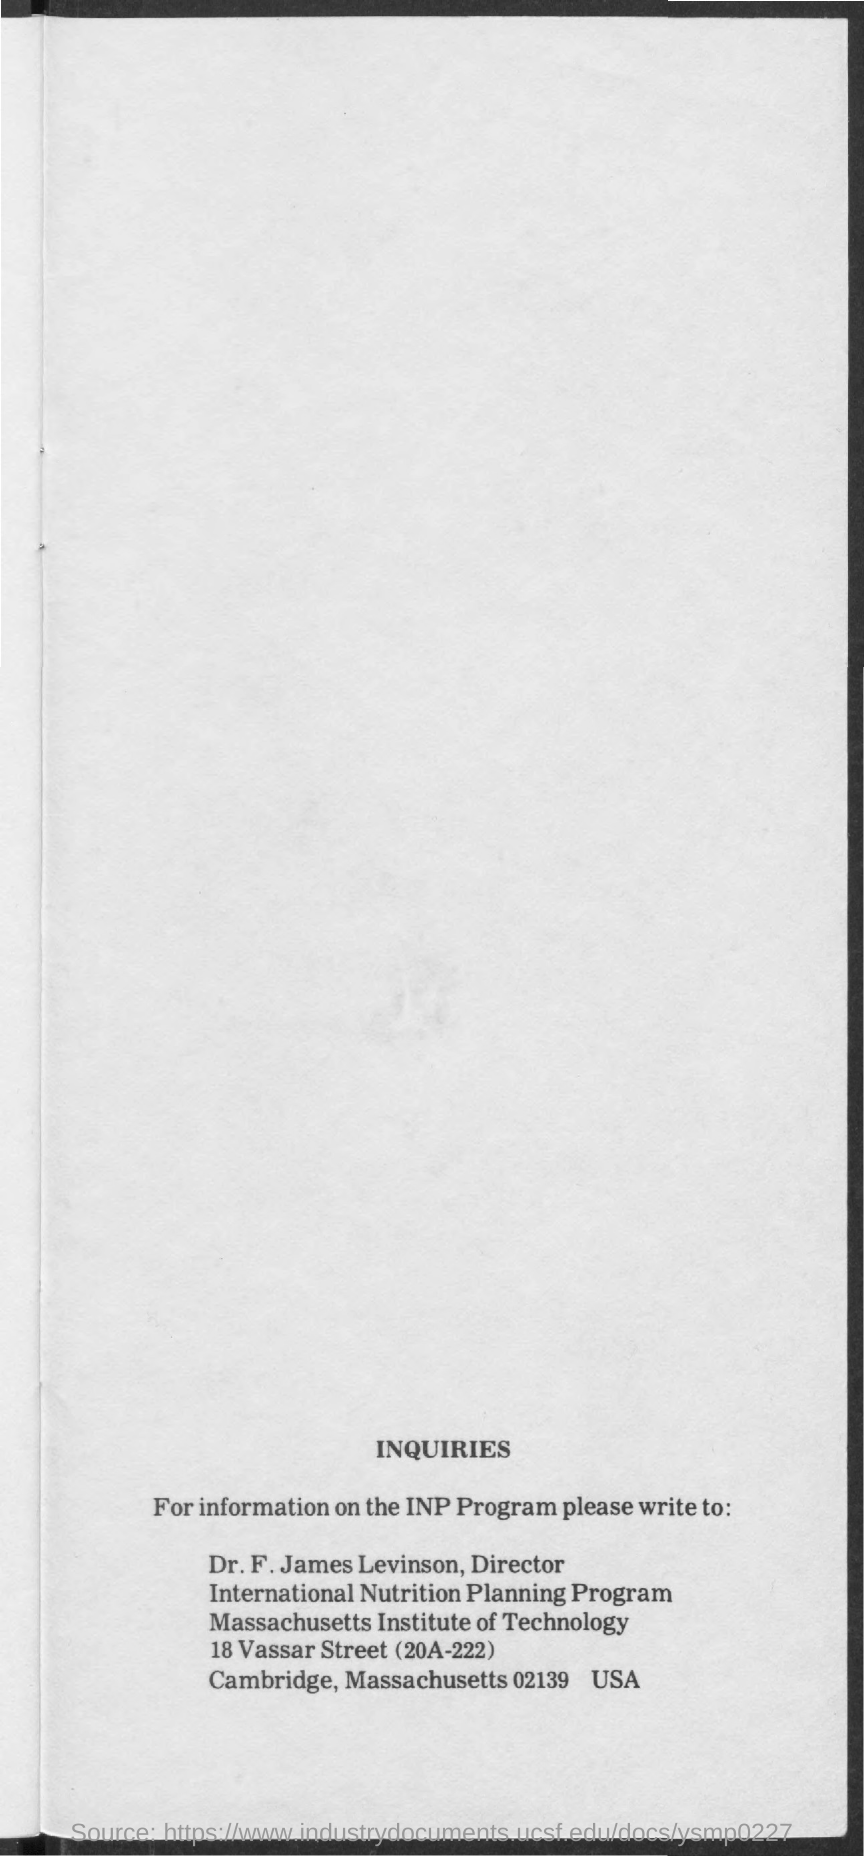Mention a couple of crucial points in this snapshot. Dr. F. James Levinson has been designated as the director. The Massachusetts Institute of Technology is a well-known institute that is often mentioned in discussions of innovative technology and cutting-edge research. The International Nutrition Planning Program is a program that focuses on planning and managing nutrition-related activities and resources in various international settings. 